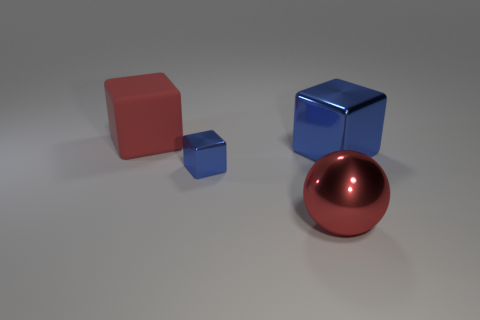Add 2 big metal cubes. How many objects exist? 6 Subtract all spheres. How many objects are left? 3 Subtract 1 red spheres. How many objects are left? 3 Subtract all big blue things. Subtract all gray rubber balls. How many objects are left? 3 Add 4 large rubber cubes. How many large rubber cubes are left? 5 Add 2 red balls. How many red balls exist? 3 